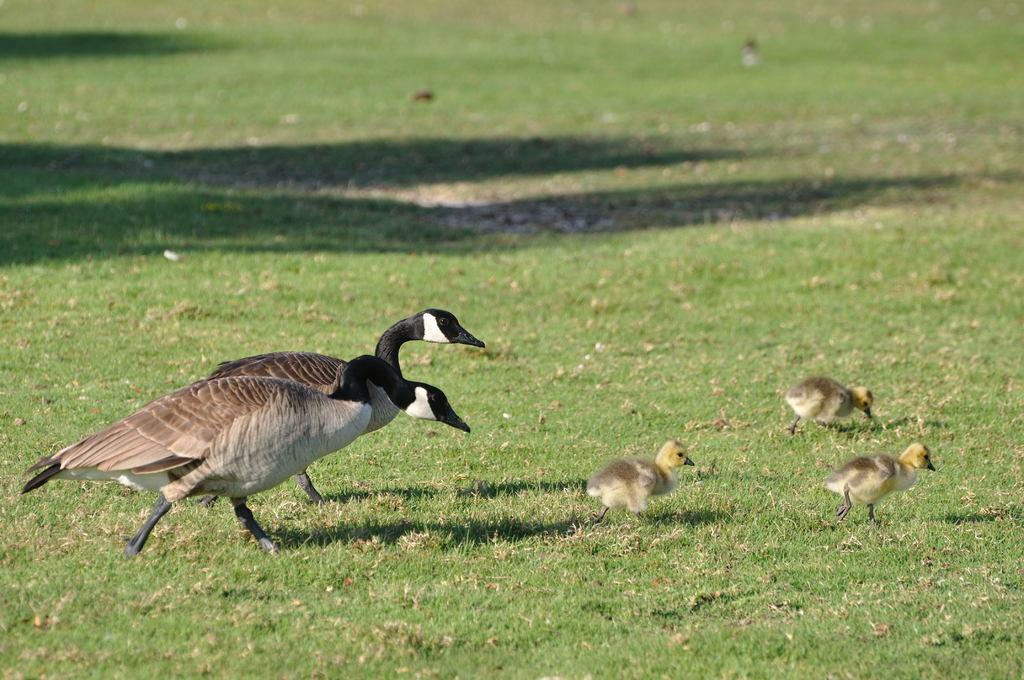What type of animals are in the foreground of the image? There are ducks and ducklings in the foreground of the image. What is the setting where the ducks and ducklings are located? The ducks and ducklings are on the grass. What type of drink is being served at the end of the image? There is no drink or end visible in the image; it features ducks and ducklings on the grass. 